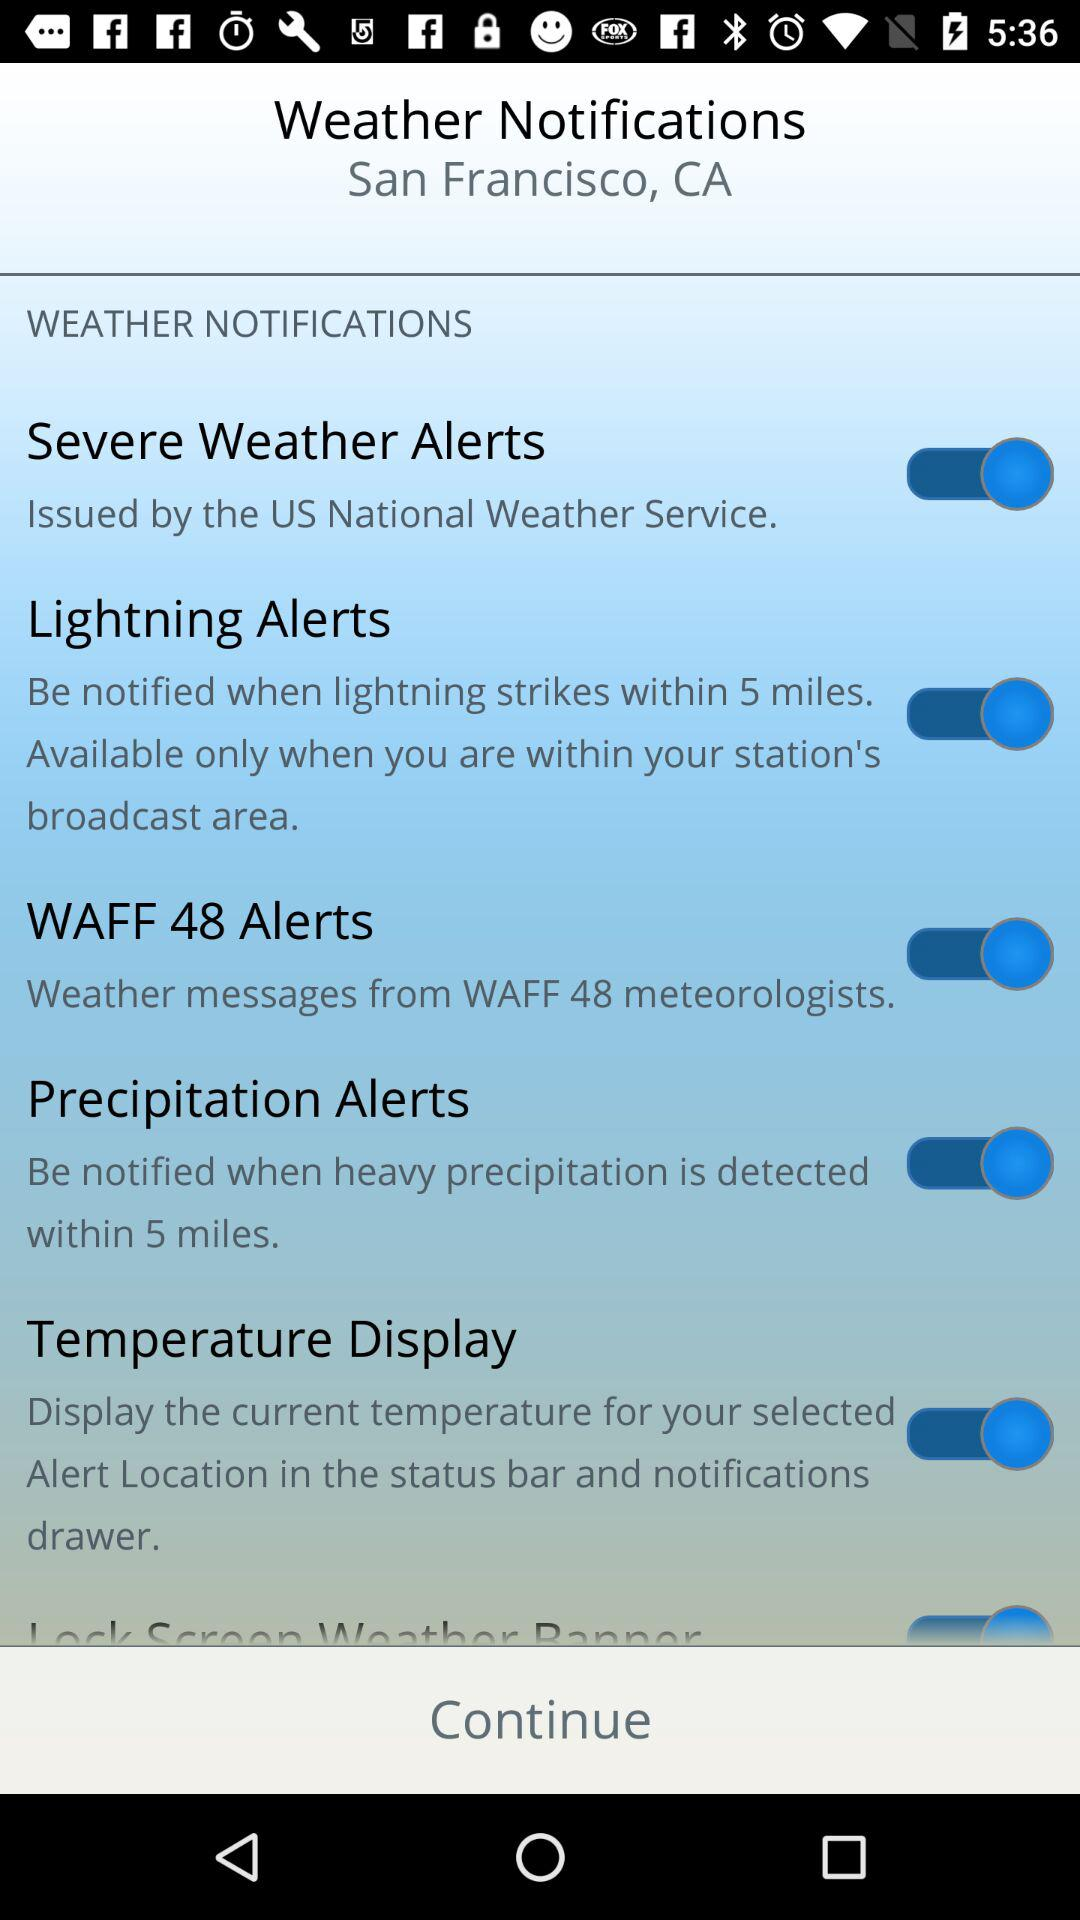What is the location? The location is San Francisco, CA. 